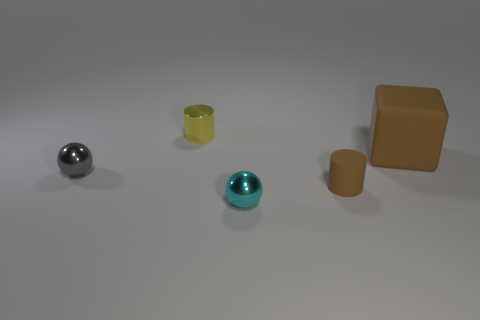Add 3 small brown cylinders. How many objects exist? 8 Subtract all gray spheres. How many spheres are left? 1 Subtract 1 blocks. How many blocks are left? 0 Subtract all cylinders. How many objects are left? 3 Subtract all blue balls. Subtract all purple blocks. How many balls are left? 2 Subtract all yellow cubes. How many yellow cylinders are left? 1 Subtract all brown matte things. Subtract all tiny red things. How many objects are left? 3 Add 5 tiny brown matte cylinders. How many tiny brown matte cylinders are left? 6 Add 5 yellow shiny cylinders. How many yellow shiny cylinders exist? 6 Subtract 0 blue cylinders. How many objects are left? 5 